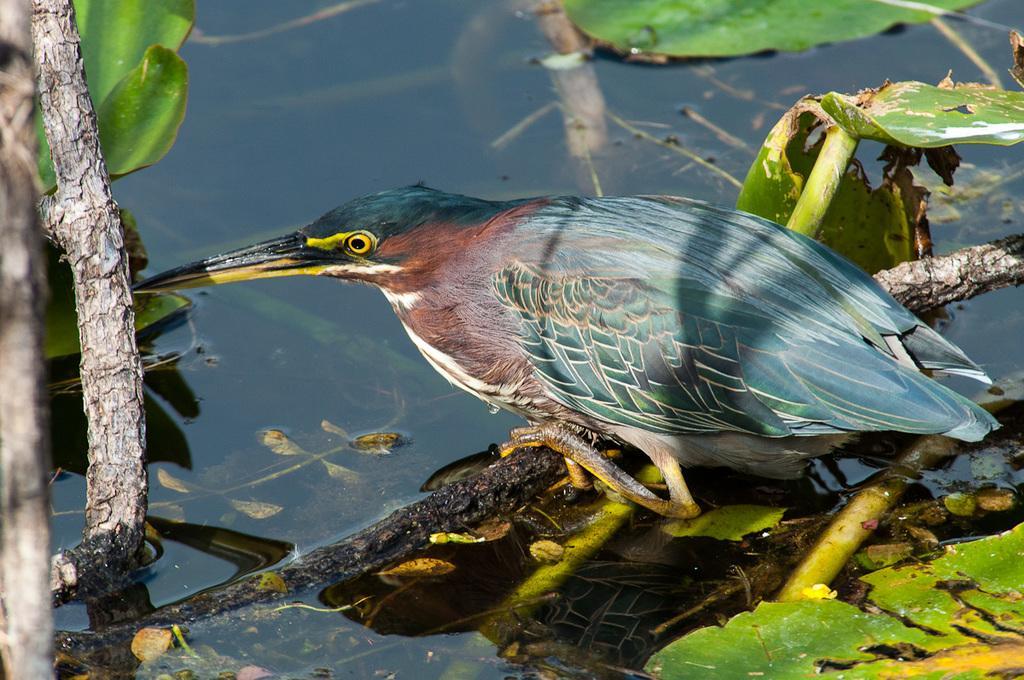Could you give a brief overview of what you see in this image? In this picture I can see there is a bird sitting on a stem of a tree and there is water here and there are some twigs and leaves in water. 